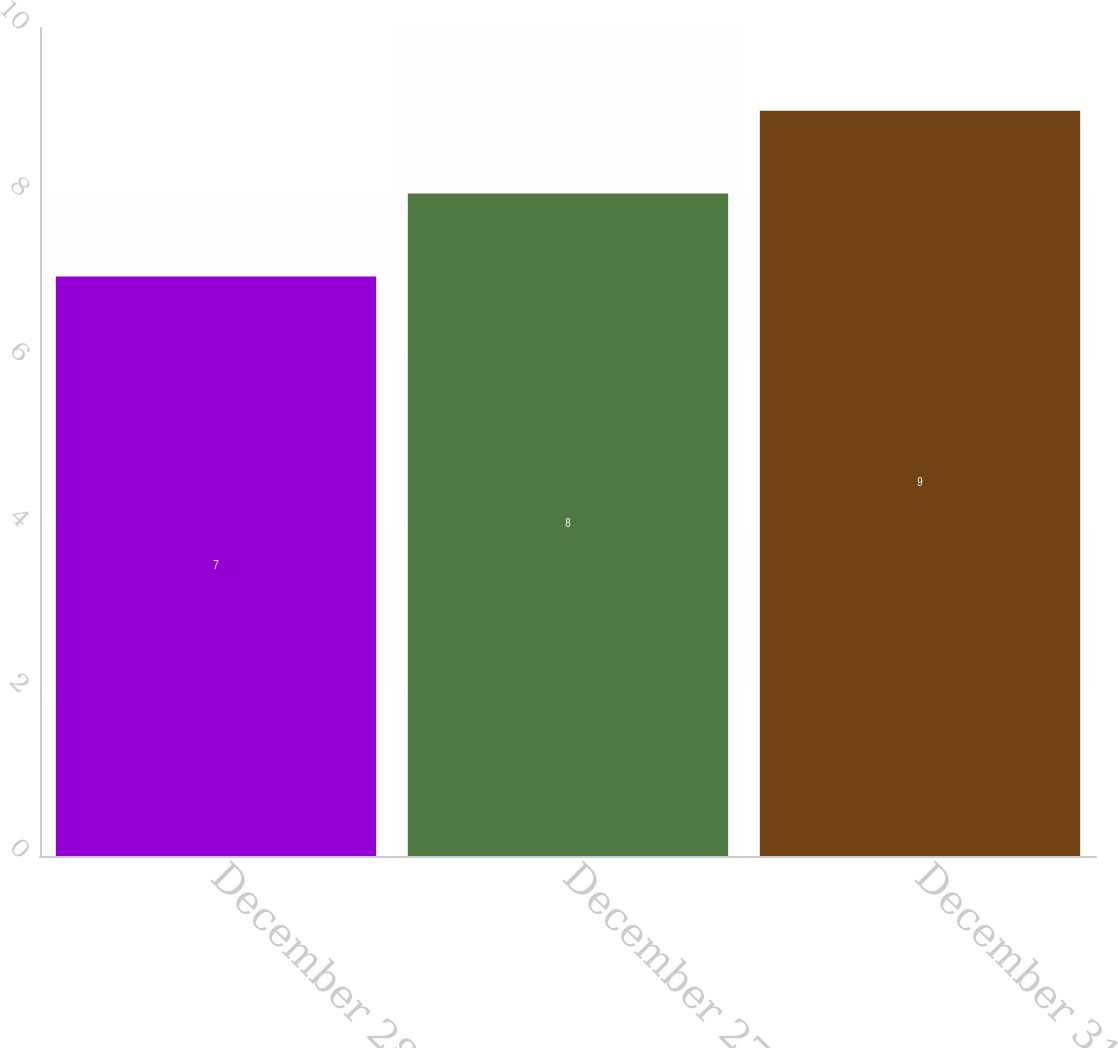Convert chart to OTSL. <chart><loc_0><loc_0><loc_500><loc_500><bar_chart><fcel>December 28 2013<fcel>December 27 2014<fcel>December 31 2016<nl><fcel>7<fcel>8<fcel>9<nl></chart> 